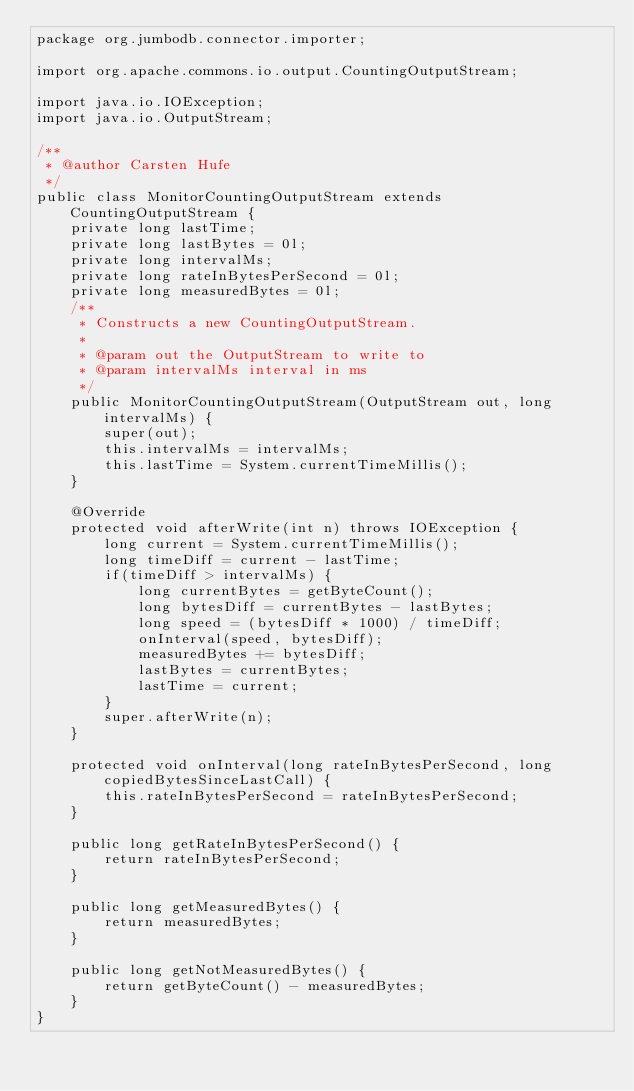Convert code to text. <code><loc_0><loc_0><loc_500><loc_500><_Java_>package org.jumbodb.connector.importer;

import org.apache.commons.io.output.CountingOutputStream;

import java.io.IOException;
import java.io.OutputStream;

/**
 * @author Carsten Hufe
 */
public class MonitorCountingOutputStream extends CountingOutputStream {
    private long lastTime;
    private long lastBytes = 0l;
    private long intervalMs;
    private long rateInBytesPerSecond = 0l;
    private long measuredBytes = 0l;
    /**
     * Constructs a new CountingOutputStream.
     *
     * @param out the OutputStream to write to
     * @param intervalMs interval in ms
     */
    public MonitorCountingOutputStream(OutputStream out, long intervalMs) {
        super(out);
        this.intervalMs = intervalMs;
        this.lastTime = System.currentTimeMillis();
    }

    @Override
    protected void afterWrite(int n) throws IOException {
        long current = System.currentTimeMillis();
        long timeDiff = current - lastTime;
        if(timeDiff > intervalMs) {
            long currentBytes = getByteCount();
            long bytesDiff = currentBytes - lastBytes;
            long speed = (bytesDiff * 1000) / timeDiff;
            onInterval(speed, bytesDiff);
            measuredBytes += bytesDiff;
            lastBytes = currentBytes;
            lastTime = current;
        }
        super.afterWrite(n);
    }

    protected void onInterval(long rateInBytesPerSecond, long copiedBytesSinceLastCall) {
        this.rateInBytesPerSecond = rateInBytesPerSecond;
    }

    public long getRateInBytesPerSecond() {
        return rateInBytesPerSecond;
    }

    public long getMeasuredBytes() {
        return measuredBytes;
    }

    public long getNotMeasuredBytes() {
        return getByteCount() - measuredBytes;
    }
}
</code> 